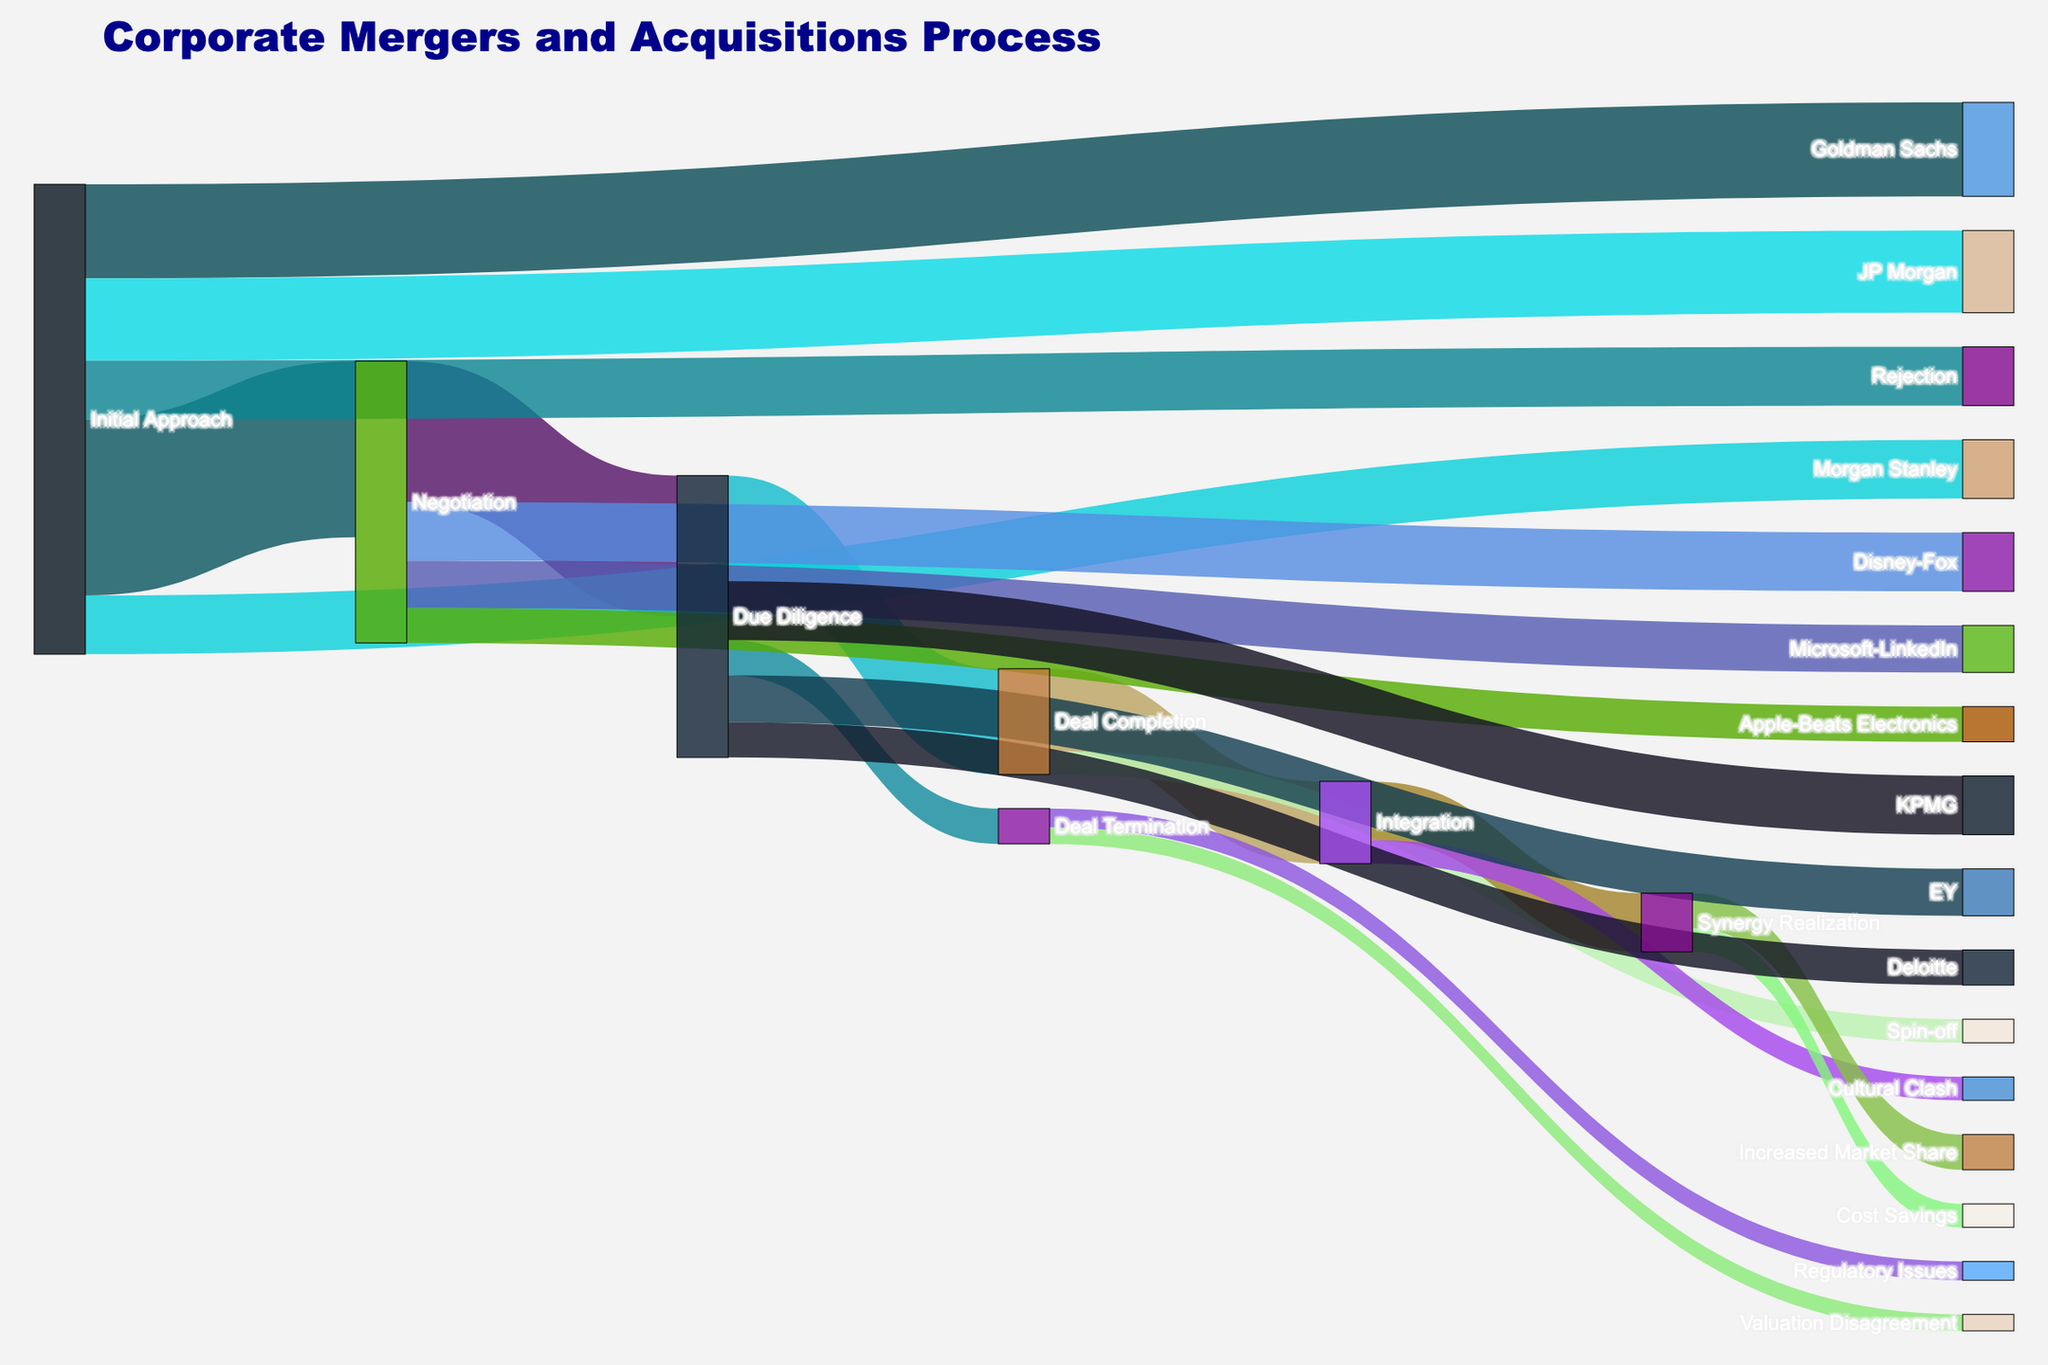How many mergers reached the Integration stage? Look at the value associated with the link from "Deal Completion" to "Integration." The value is 35, indicating that 35 mergers reached the Integration stage.
Answer: 35 Which stage has the highest value flowing out of 'Deal Completion'? To determine this, compare the values of the links flowing out of "Deal Completion" to "Integration" and "Spin-off." "Integration" has a value of 35 and "Spin-off" has a value of 10. Therefore, "Integration" has the highest value.
Answer: Integration What is the total number of mergers that started with an Initial Approach? Sum the values flowing out of "Initial Approach" to "Negotiation" and "Rejection." The values are 75 and 25, respectively. So, the total number of mergers that started with an Initial Approach is 75 + 25 = 100.
Answer: 100 Which consulting firm handled the fewest due diligence cases? Compare the values of links flowing from "Due Diligence" to "EY," "KPMG," and "Deloitte." "Deloitte" has a value of 15, which is the smallest compared to "EY" (20) and "KPMG" (25).
Answer: Deloitte What is the total value for deals that progressed from Due Diligence? Sum the values flowing out of "Due Diligence" to "Deal Completion" and "Deal Termination." The values are 45 and 15, respectively. So the total value is 45 + 15 = 60.
Answer: 60 Which bank was involved in the highest number of initial approaches? Compare the values next to "Goldman Sachs," "JP Morgan," and "Morgan Stanley." "Goldman Sachs" has the highest value of 40, compared to "JP Morgan" (35) and "Morgan Stanley" (25).
Answer: Goldman Sachs What are the two outcomes for the Integration stage, and what are their respective values? The outcomes from "Integration" are shown by the links leading to "Synergy Realization" and "Cultural Clash." The values are 25 for "Synergy Realization" and 10 for "Cultural Clash."
Answer: Synergy Realization: 25, Cultural Clash: 10 Which deal had the highest number of negotiations? Among "Apple-Beats Electronics," "Microsoft-LinkedIn," and "Disney-Fox," "Disney-Fox" has the highest value of 25 in negotiations.
Answer: Disney-Fox How does the figure title relate to the data displayed? The title "Corporate Mergers and Acquisitions Process" encapsulates the various stages and outcomes involved in corporate mergers and acquisitions, from the Initial Approach to the final stages like Integration and Synergy Realization. The Sankey diagram visualizes these stages and their respective flows.
Answer: The title summarizes the process stages and outcomes in corporate mergers and acquisitions How do the values from "Synergy Realization" distribute to its final outcomes? "Synergy Realization" leads to "Increased Market Share" and "Cost Savings." The values are 15 and 10, respectively.
Answer: Increased Market Share: 15, Cost Savings: 10 